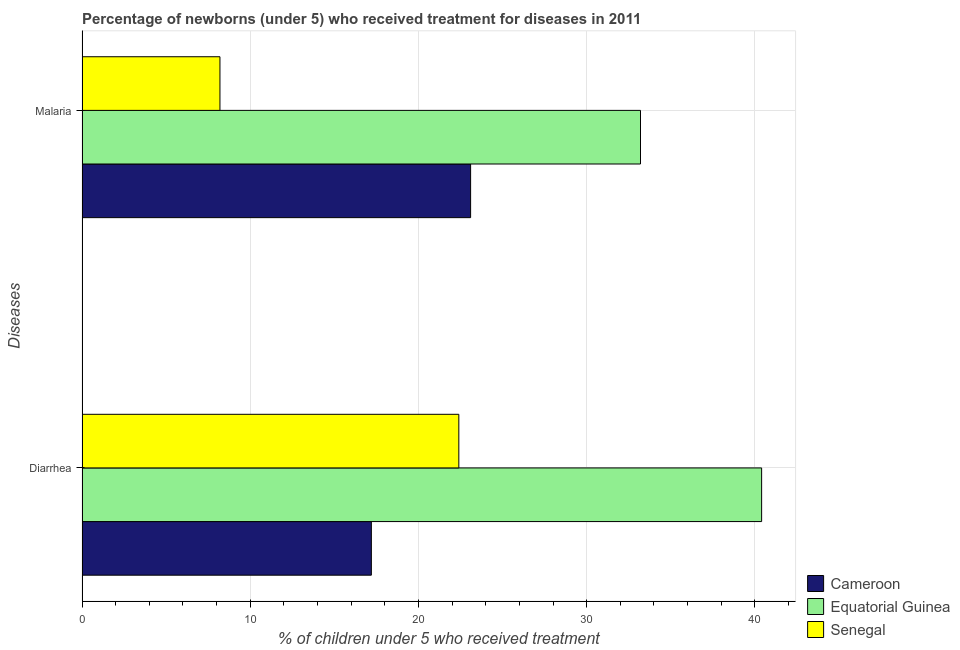How many groups of bars are there?
Give a very brief answer. 2. Are the number of bars per tick equal to the number of legend labels?
Keep it short and to the point. Yes. How many bars are there on the 2nd tick from the top?
Give a very brief answer. 3. What is the label of the 2nd group of bars from the top?
Offer a very short reply. Diarrhea. What is the percentage of children who received treatment for diarrhoea in Equatorial Guinea?
Offer a very short reply. 40.4. Across all countries, what is the maximum percentage of children who received treatment for malaria?
Keep it short and to the point. 33.2. In which country was the percentage of children who received treatment for malaria maximum?
Your answer should be compact. Equatorial Guinea. In which country was the percentage of children who received treatment for malaria minimum?
Offer a terse response. Senegal. What is the total percentage of children who received treatment for diarrhoea in the graph?
Ensure brevity in your answer.  80. What is the difference between the percentage of children who received treatment for malaria in Equatorial Guinea and that in Cameroon?
Provide a succinct answer. 10.1. What is the difference between the percentage of children who received treatment for diarrhoea in Equatorial Guinea and the percentage of children who received treatment for malaria in Senegal?
Your answer should be compact. 32.2. What is the difference between the percentage of children who received treatment for malaria and percentage of children who received treatment for diarrhoea in Cameroon?
Offer a terse response. 5.9. What is the ratio of the percentage of children who received treatment for diarrhoea in Senegal to that in Cameroon?
Make the answer very short. 1.3. Is the percentage of children who received treatment for malaria in Equatorial Guinea less than that in Cameroon?
Give a very brief answer. No. In how many countries, is the percentage of children who received treatment for diarrhoea greater than the average percentage of children who received treatment for diarrhoea taken over all countries?
Offer a very short reply. 1. What does the 2nd bar from the top in Malaria represents?
Provide a short and direct response. Equatorial Guinea. What does the 2nd bar from the bottom in Malaria represents?
Provide a short and direct response. Equatorial Guinea. How many bars are there?
Keep it short and to the point. 6. How many countries are there in the graph?
Your answer should be very brief. 3. Are the values on the major ticks of X-axis written in scientific E-notation?
Your response must be concise. No. Does the graph contain any zero values?
Provide a short and direct response. No. What is the title of the graph?
Make the answer very short. Percentage of newborns (under 5) who received treatment for diseases in 2011. What is the label or title of the X-axis?
Give a very brief answer. % of children under 5 who received treatment. What is the label or title of the Y-axis?
Offer a terse response. Diseases. What is the % of children under 5 who received treatment of Equatorial Guinea in Diarrhea?
Your answer should be compact. 40.4. What is the % of children under 5 who received treatment of Senegal in Diarrhea?
Give a very brief answer. 22.4. What is the % of children under 5 who received treatment in Cameroon in Malaria?
Your response must be concise. 23.1. What is the % of children under 5 who received treatment in Equatorial Guinea in Malaria?
Keep it short and to the point. 33.2. Across all Diseases, what is the maximum % of children under 5 who received treatment in Cameroon?
Provide a succinct answer. 23.1. Across all Diseases, what is the maximum % of children under 5 who received treatment of Equatorial Guinea?
Provide a succinct answer. 40.4. Across all Diseases, what is the maximum % of children under 5 who received treatment in Senegal?
Give a very brief answer. 22.4. Across all Diseases, what is the minimum % of children under 5 who received treatment of Cameroon?
Your response must be concise. 17.2. Across all Diseases, what is the minimum % of children under 5 who received treatment in Equatorial Guinea?
Ensure brevity in your answer.  33.2. What is the total % of children under 5 who received treatment of Cameroon in the graph?
Your answer should be very brief. 40.3. What is the total % of children under 5 who received treatment in Equatorial Guinea in the graph?
Provide a succinct answer. 73.6. What is the total % of children under 5 who received treatment in Senegal in the graph?
Your answer should be compact. 30.6. What is the difference between the % of children under 5 who received treatment of Senegal in Diarrhea and that in Malaria?
Make the answer very short. 14.2. What is the difference between the % of children under 5 who received treatment of Equatorial Guinea in Diarrhea and the % of children under 5 who received treatment of Senegal in Malaria?
Offer a very short reply. 32.2. What is the average % of children under 5 who received treatment of Cameroon per Diseases?
Ensure brevity in your answer.  20.15. What is the average % of children under 5 who received treatment of Equatorial Guinea per Diseases?
Keep it short and to the point. 36.8. What is the average % of children under 5 who received treatment of Senegal per Diseases?
Keep it short and to the point. 15.3. What is the difference between the % of children under 5 who received treatment of Cameroon and % of children under 5 who received treatment of Equatorial Guinea in Diarrhea?
Ensure brevity in your answer.  -23.2. What is the difference between the % of children under 5 who received treatment in Cameroon and % of children under 5 who received treatment in Senegal in Malaria?
Your answer should be compact. 14.9. What is the difference between the % of children under 5 who received treatment of Equatorial Guinea and % of children under 5 who received treatment of Senegal in Malaria?
Provide a short and direct response. 25. What is the ratio of the % of children under 5 who received treatment in Cameroon in Diarrhea to that in Malaria?
Keep it short and to the point. 0.74. What is the ratio of the % of children under 5 who received treatment of Equatorial Guinea in Diarrhea to that in Malaria?
Your answer should be very brief. 1.22. What is the ratio of the % of children under 5 who received treatment of Senegal in Diarrhea to that in Malaria?
Provide a short and direct response. 2.73. What is the difference between the highest and the second highest % of children under 5 who received treatment in Senegal?
Your response must be concise. 14.2. What is the difference between the highest and the lowest % of children under 5 who received treatment in Cameroon?
Give a very brief answer. 5.9. What is the difference between the highest and the lowest % of children under 5 who received treatment of Equatorial Guinea?
Provide a succinct answer. 7.2. What is the difference between the highest and the lowest % of children under 5 who received treatment in Senegal?
Your response must be concise. 14.2. 